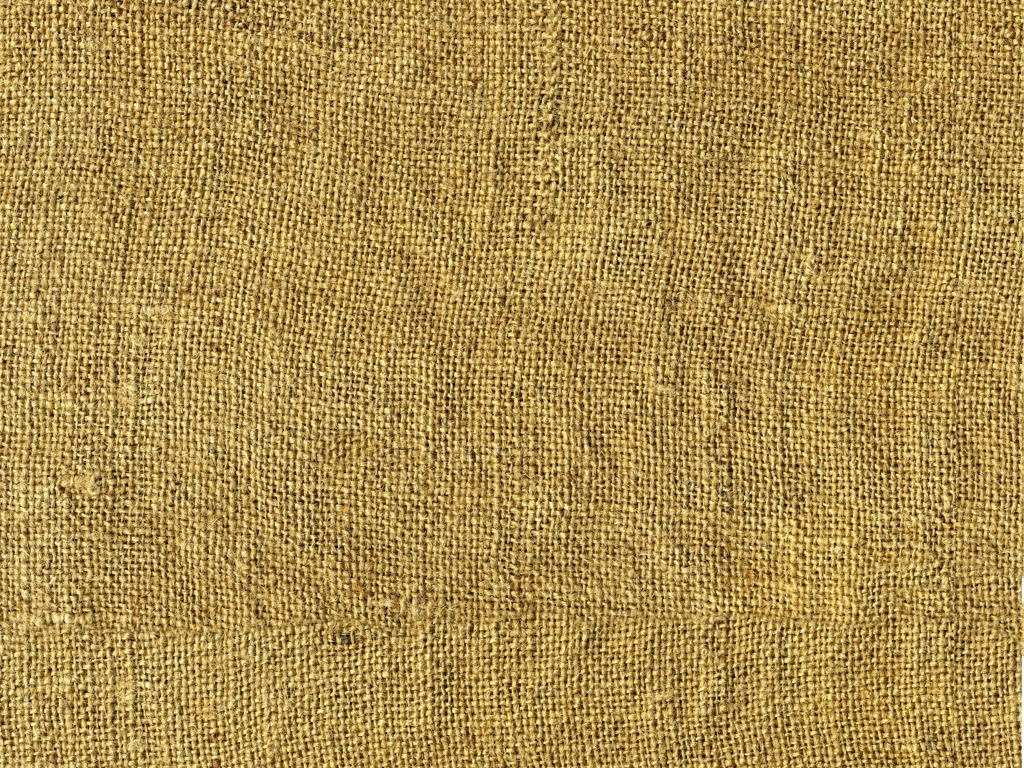Does the image have any quality issues related to color?
A. No
B. Yes
Answer with the option's letter from the given choices directly.
 A. 